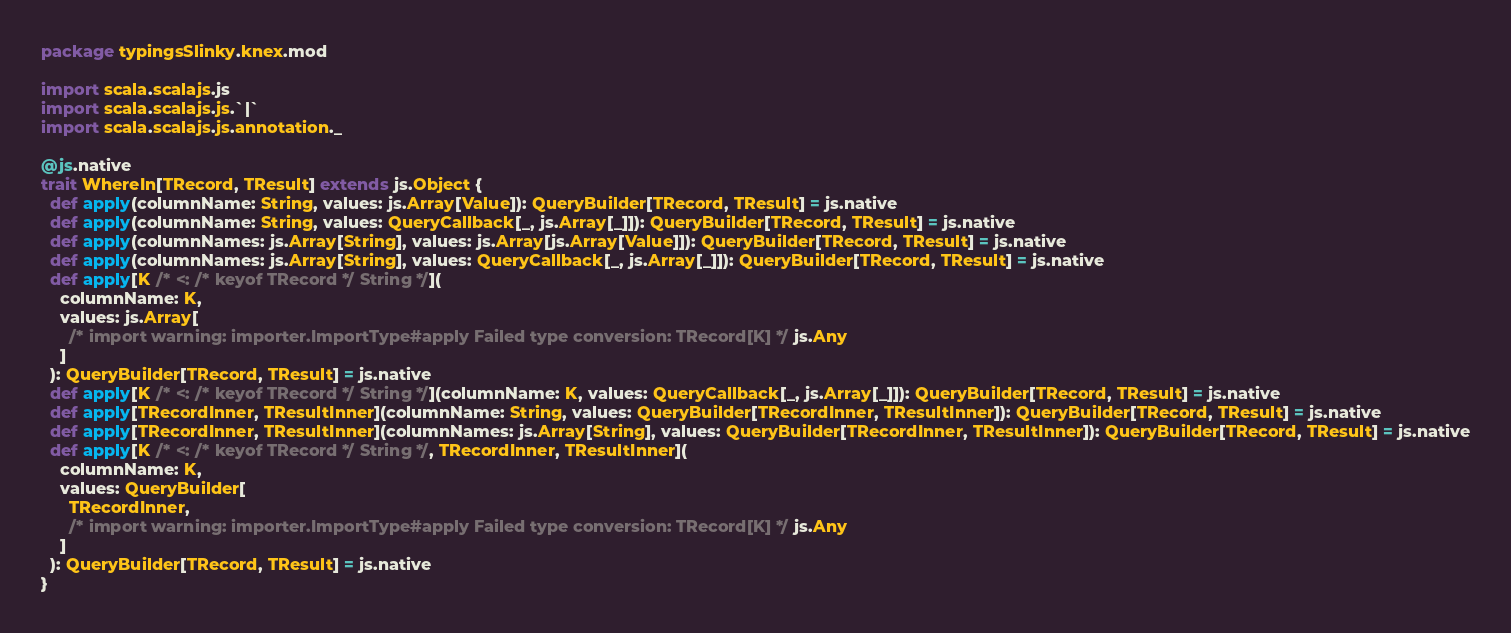<code> <loc_0><loc_0><loc_500><loc_500><_Scala_>package typingsSlinky.knex.mod

import scala.scalajs.js
import scala.scalajs.js.`|`
import scala.scalajs.js.annotation._

@js.native
trait WhereIn[TRecord, TResult] extends js.Object {
  def apply(columnName: String, values: js.Array[Value]): QueryBuilder[TRecord, TResult] = js.native
  def apply(columnName: String, values: QueryCallback[_, js.Array[_]]): QueryBuilder[TRecord, TResult] = js.native
  def apply(columnNames: js.Array[String], values: js.Array[js.Array[Value]]): QueryBuilder[TRecord, TResult] = js.native
  def apply(columnNames: js.Array[String], values: QueryCallback[_, js.Array[_]]): QueryBuilder[TRecord, TResult] = js.native
  def apply[K /* <: /* keyof TRecord */ String */](
    columnName: K,
    values: js.Array[
      /* import warning: importer.ImportType#apply Failed type conversion: TRecord[K] */ js.Any
    ]
  ): QueryBuilder[TRecord, TResult] = js.native
  def apply[K /* <: /* keyof TRecord */ String */](columnName: K, values: QueryCallback[_, js.Array[_]]): QueryBuilder[TRecord, TResult] = js.native
  def apply[TRecordInner, TResultInner](columnName: String, values: QueryBuilder[TRecordInner, TResultInner]): QueryBuilder[TRecord, TResult] = js.native
  def apply[TRecordInner, TResultInner](columnNames: js.Array[String], values: QueryBuilder[TRecordInner, TResultInner]): QueryBuilder[TRecord, TResult] = js.native
  def apply[K /* <: /* keyof TRecord */ String */, TRecordInner, TResultInner](
    columnName: K,
    values: QueryBuilder[
      TRecordInner, 
      /* import warning: importer.ImportType#apply Failed type conversion: TRecord[K] */ js.Any
    ]
  ): QueryBuilder[TRecord, TResult] = js.native
}

</code> 